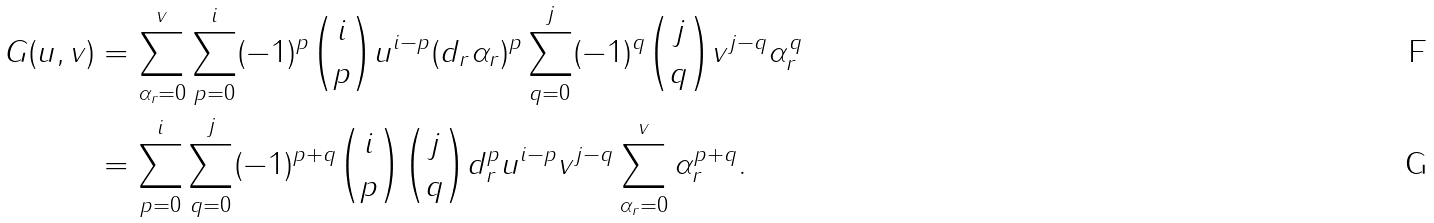Convert formula to latex. <formula><loc_0><loc_0><loc_500><loc_500>G ( u , v ) & = \sum _ { \alpha _ { r } = 0 } ^ { v } \sum _ { p = 0 } ^ { i } ( - 1 ) ^ { p } { i \choose p } u ^ { i - p } ( d _ { r } \alpha _ { r } ) ^ { p } \sum _ { q = 0 } ^ { j } ( - 1 ) ^ { q } { j \choose q } v ^ { j - q } \alpha _ { r } ^ { q } \\ & = \sum _ { p = 0 } ^ { i } \sum _ { q = 0 } ^ { j } ( - 1 ) ^ { p + q } { i \choose p } { j \choose q } d _ { r } ^ { p } u ^ { i - p } v ^ { j - q } \sum _ { \alpha _ { r } = 0 } ^ { v } \alpha _ { r } ^ { p + q } .</formula> 